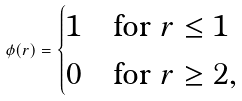Convert formula to latex. <formula><loc_0><loc_0><loc_500><loc_500>\phi ( r ) = \begin{cases} 1 & \text {for } r \leq 1 \\ 0 & \text {for } r \geq 2 , \end{cases}</formula> 